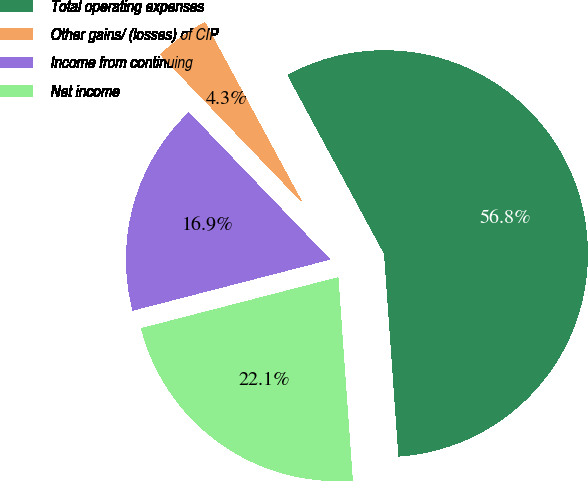<chart> <loc_0><loc_0><loc_500><loc_500><pie_chart><fcel>Total operating expenses<fcel>Other gains/ (losses) of CIP<fcel>Income from continuing<fcel>Net income<nl><fcel>56.76%<fcel>4.29%<fcel>16.85%<fcel>22.1%<nl></chart> 